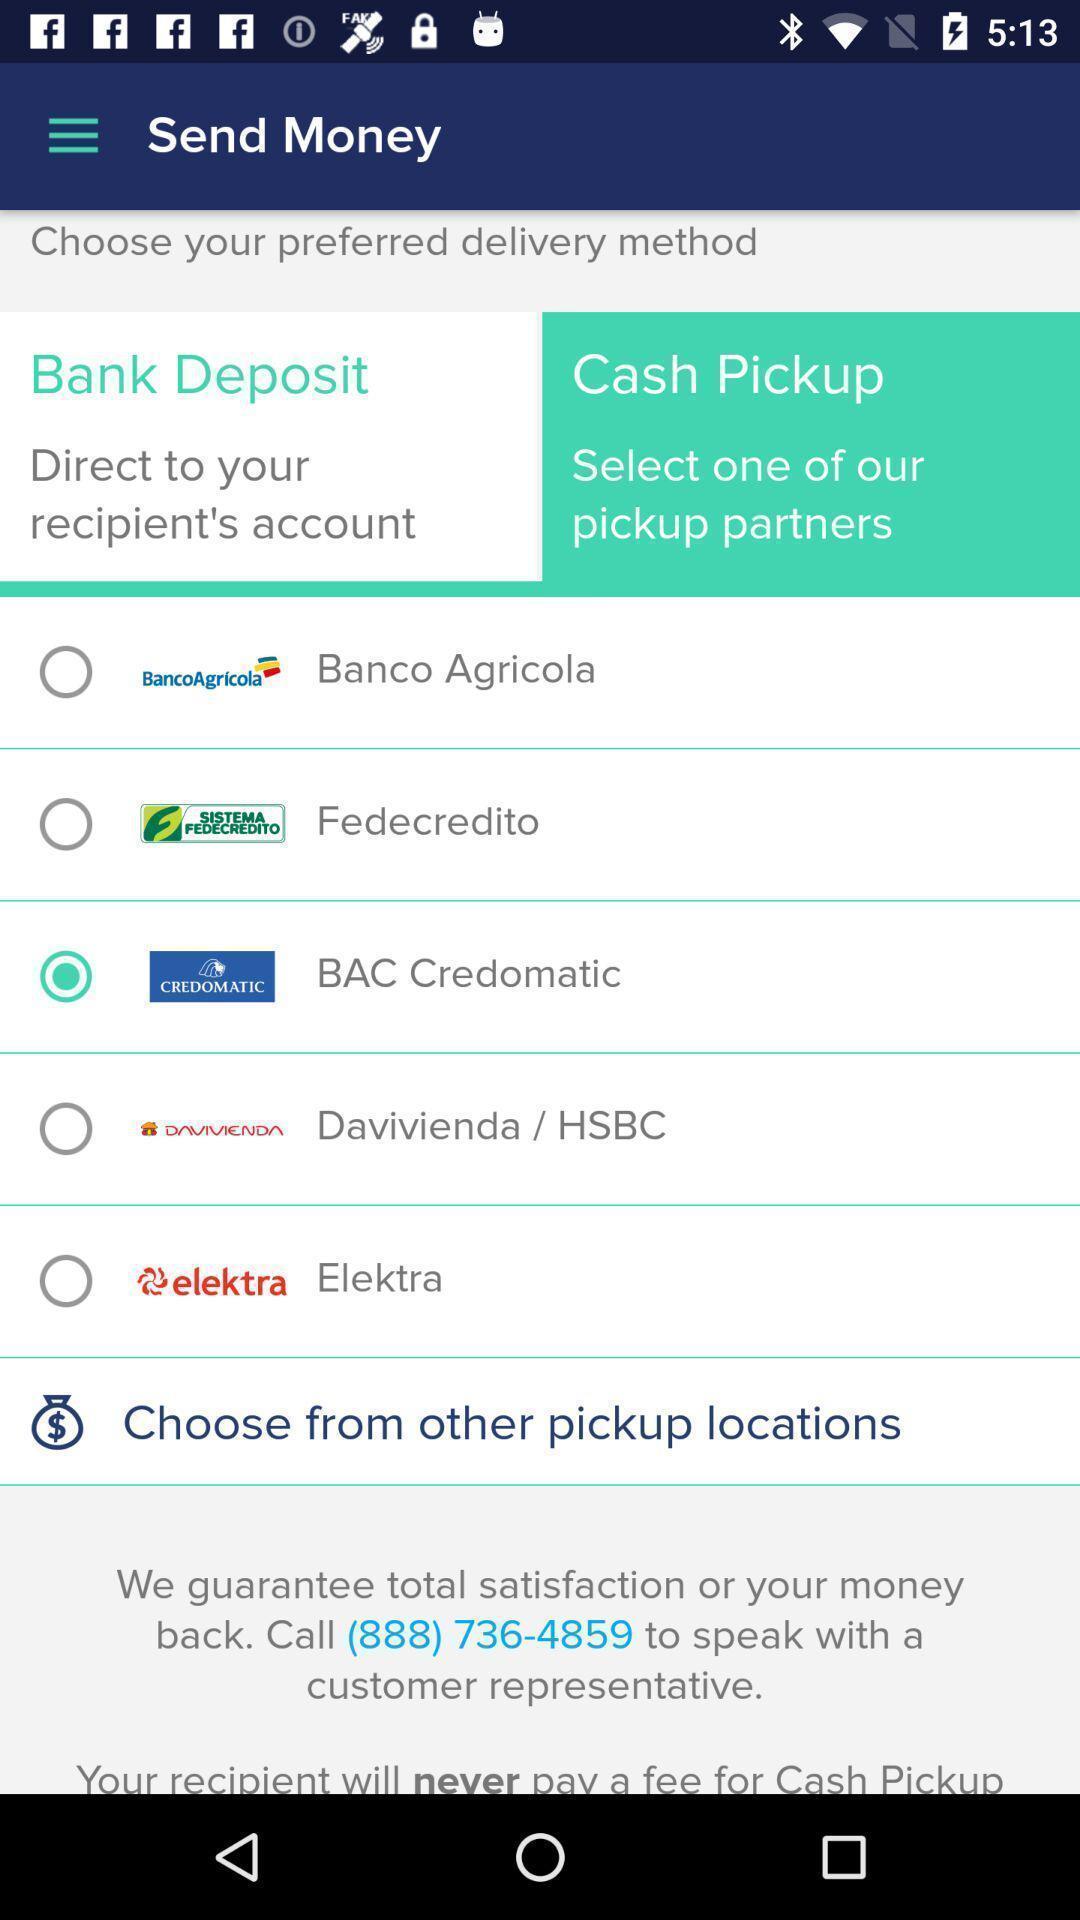Explain the elements present in this screenshot. Screen asking to send money through different options. 